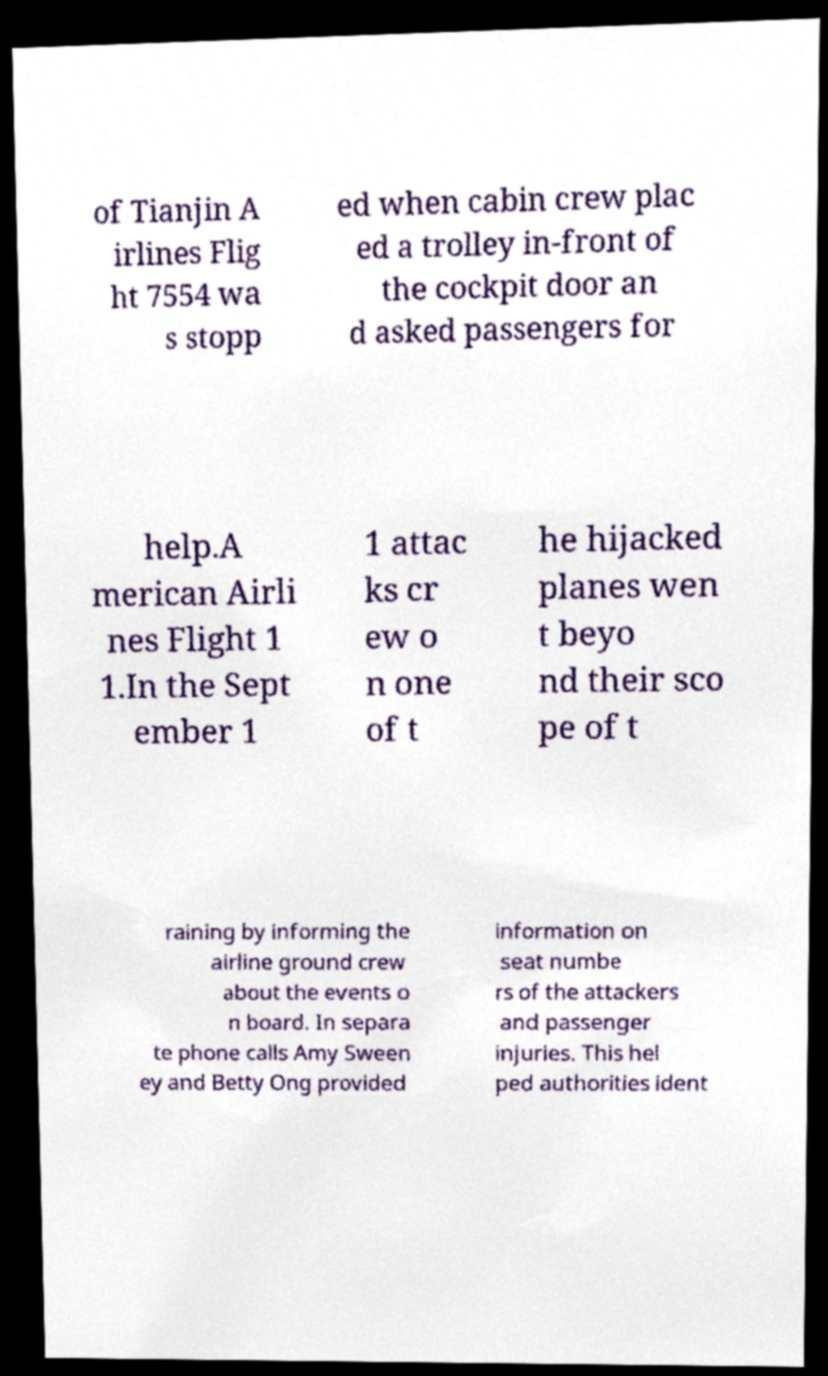Could you extract and type out the text from this image? of Tianjin A irlines Flig ht 7554 wa s stopp ed when cabin crew plac ed a trolley in-front of the cockpit door an d asked passengers for help.A merican Airli nes Flight 1 1.In the Sept ember 1 1 attac ks cr ew o n one of t he hijacked planes wen t beyo nd their sco pe of t raining by informing the airline ground crew about the events o n board. In separa te phone calls Amy Sween ey and Betty Ong provided information on seat numbe rs of the attackers and passenger injuries. This hel ped authorities ident 